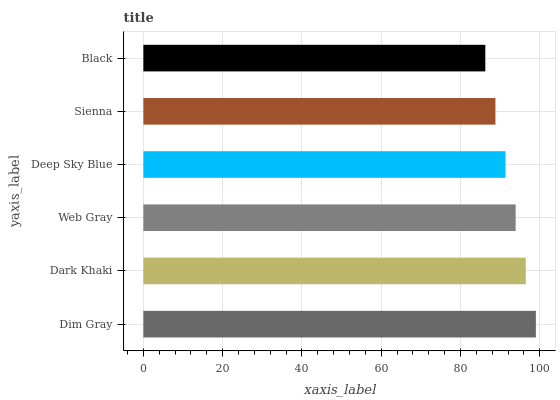Is Black the minimum?
Answer yes or no. Yes. Is Dim Gray the maximum?
Answer yes or no. Yes. Is Dark Khaki the minimum?
Answer yes or no. No. Is Dark Khaki the maximum?
Answer yes or no. No. Is Dim Gray greater than Dark Khaki?
Answer yes or no. Yes. Is Dark Khaki less than Dim Gray?
Answer yes or no. Yes. Is Dark Khaki greater than Dim Gray?
Answer yes or no. No. Is Dim Gray less than Dark Khaki?
Answer yes or no. No. Is Web Gray the high median?
Answer yes or no. Yes. Is Deep Sky Blue the low median?
Answer yes or no. Yes. Is Dim Gray the high median?
Answer yes or no. No. Is Black the low median?
Answer yes or no. No. 